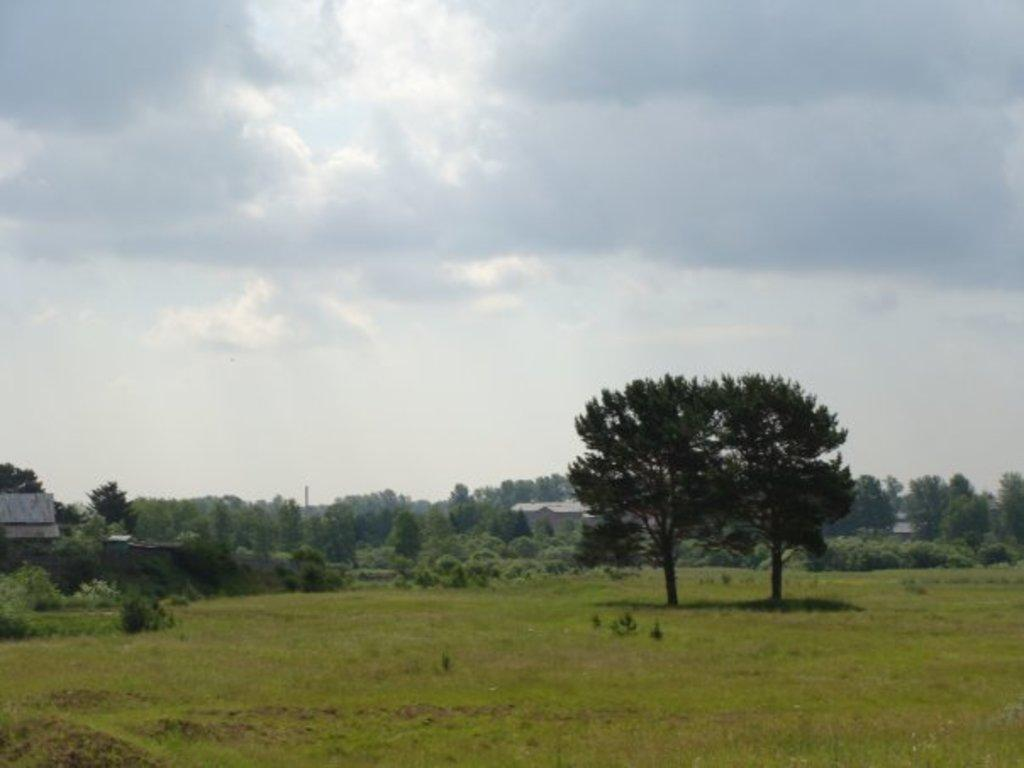What type of terrain is visible in the foreground of the image? There is grassland and trees in the foreground of the image. What structures can be seen in the image? There are buildings visible in the image. What is visible in the background of the image? The sky is visible in the image. What can be observed in the sky? There are clouds in the sky. What type of pen is being used to draw on the grass in the image? There is no pen or drawing activity present in the image; it features grassland, trees, buildings, and a sky with clouds. 